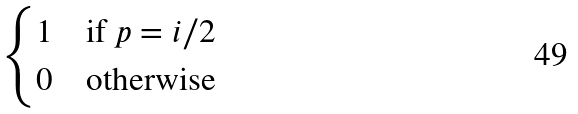<formula> <loc_0><loc_0><loc_500><loc_500>\begin{cases} 1 & \text {if $p=i/2$} \\ 0 & \text {otherwise} \end{cases}</formula> 